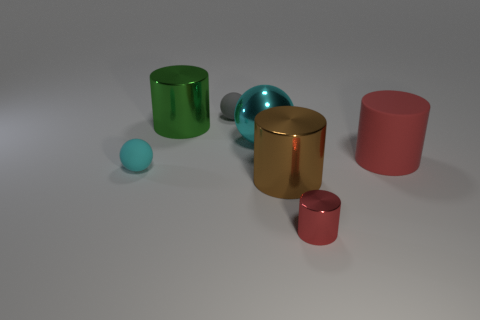What number of things are either small red cylinders or large green objects?
Provide a succinct answer. 2. Are there any small red objects of the same shape as the brown metallic object?
Your answer should be very brief. Yes. There is a rubber sphere in front of the small gray thing; is its color the same as the large ball?
Make the answer very short. Yes. What shape is the large shiny thing left of the cyan sphere that is behind the big red thing?
Make the answer very short. Cylinder. Is there a red cylinder of the same size as the gray ball?
Provide a short and direct response. Yes. Is the number of large brown cylinders less than the number of green metal balls?
Provide a succinct answer. No. What shape is the metallic object on the left side of the tiny matte sphere behind the cyan ball to the right of the small cyan ball?
Ensure brevity in your answer.  Cylinder. How many objects are large metal objects in front of the big cyan shiny sphere or rubber things left of the big red matte thing?
Offer a terse response. 3. Are there any small matte objects on the right side of the big red matte object?
Make the answer very short. No. What number of objects are metal cylinders that are behind the big rubber cylinder or purple metal cylinders?
Keep it short and to the point. 1. 